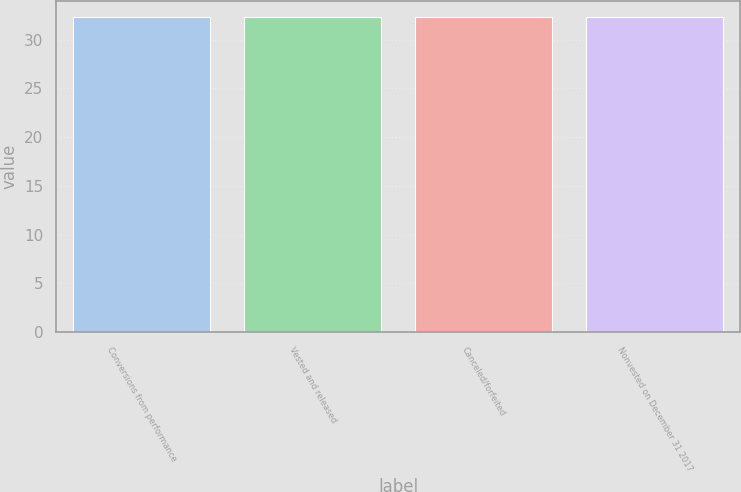Convert chart to OTSL. <chart><loc_0><loc_0><loc_500><loc_500><bar_chart><fcel>Conversions from performance<fcel>Vested and released<fcel>Canceled/forfeited<fcel>Nonvested on December 31 2017<nl><fcel>32.33<fcel>32.35<fcel>32.3<fcel>32.36<nl></chart> 